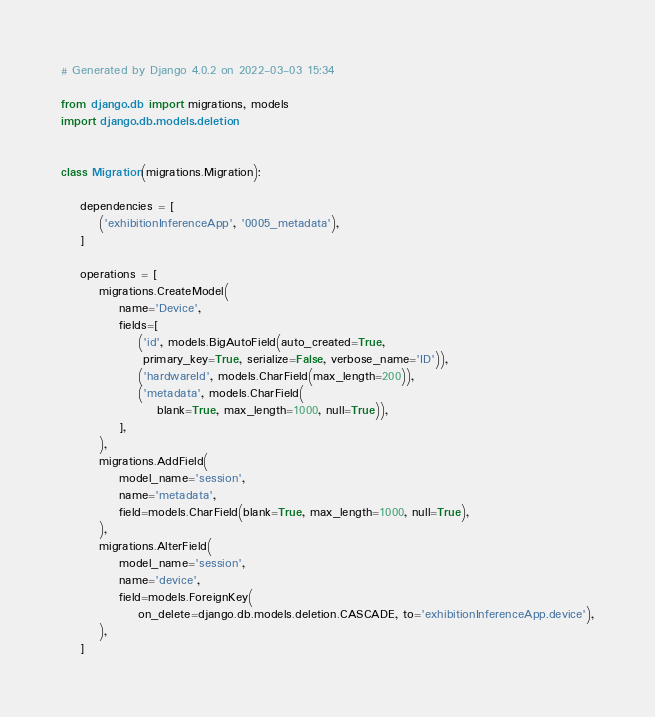<code> <loc_0><loc_0><loc_500><loc_500><_Python_># Generated by Django 4.0.2 on 2022-03-03 15:34

from django.db import migrations, models
import django.db.models.deletion


class Migration(migrations.Migration):

    dependencies = [
        ('exhibitionInferenceApp', '0005_metadata'),
    ]

    operations = [
        migrations.CreateModel(
            name='Device',
            fields=[
                ('id', models.BigAutoField(auto_created=True,
                 primary_key=True, serialize=False, verbose_name='ID')),
                ('hardwareId', models.CharField(max_length=200)),
                ('metadata', models.CharField(
                    blank=True, max_length=1000, null=True)),
            ],
        ),
        migrations.AddField(
            model_name='session',
            name='metadata',
            field=models.CharField(blank=True, max_length=1000, null=True),
        ),
        migrations.AlterField(
            model_name='session',
            name='device',
            field=models.ForeignKey(
                on_delete=django.db.models.deletion.CASCADE, to='exhibitionInferenceApp.device'),
        ),
    ]
</code> 